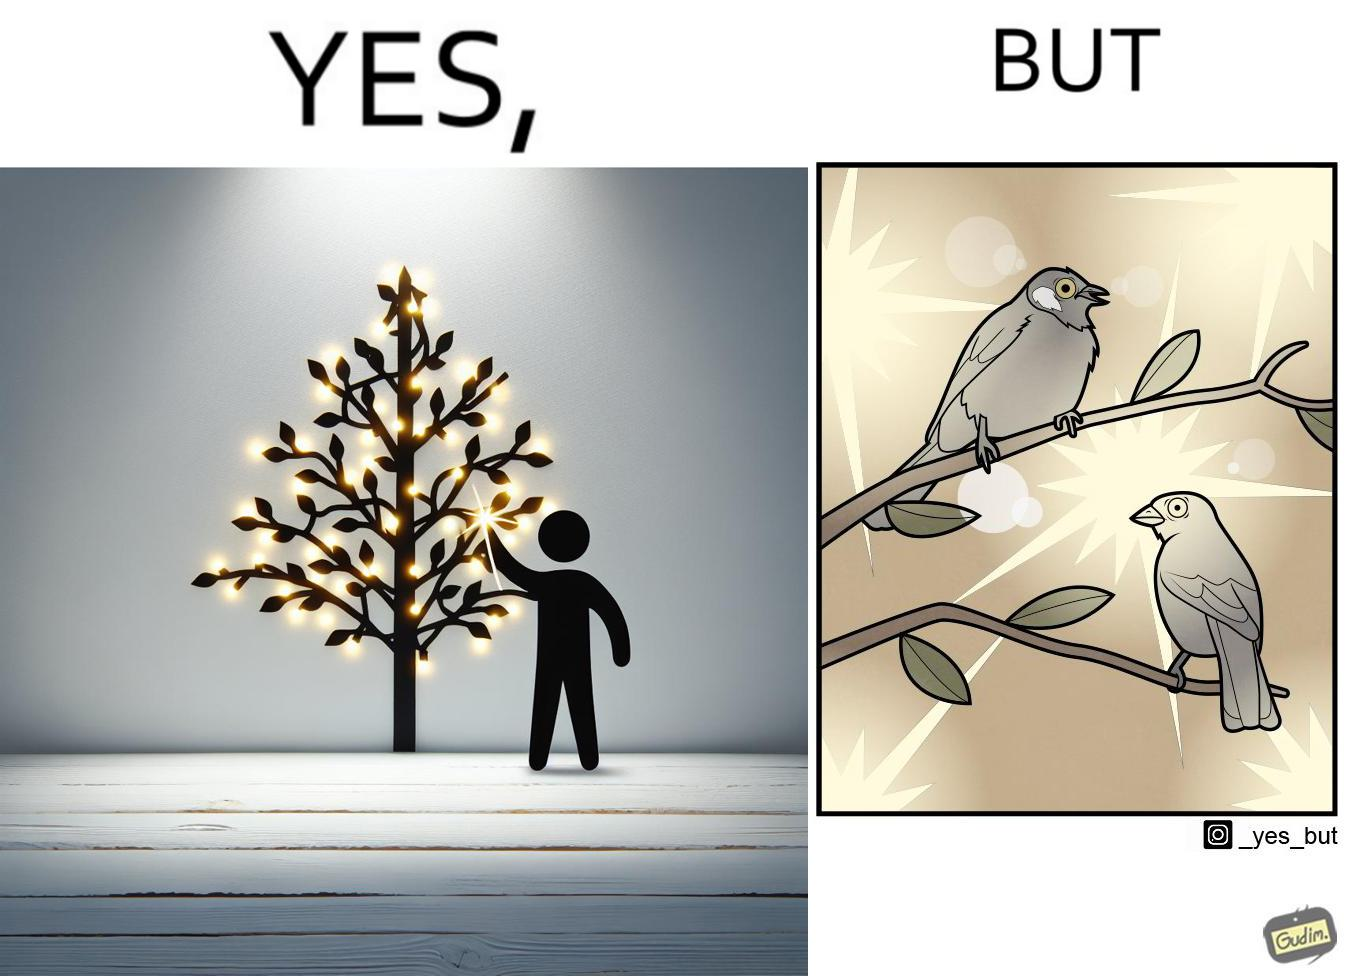Is this a satirical image? Yes, this image is satirical. 